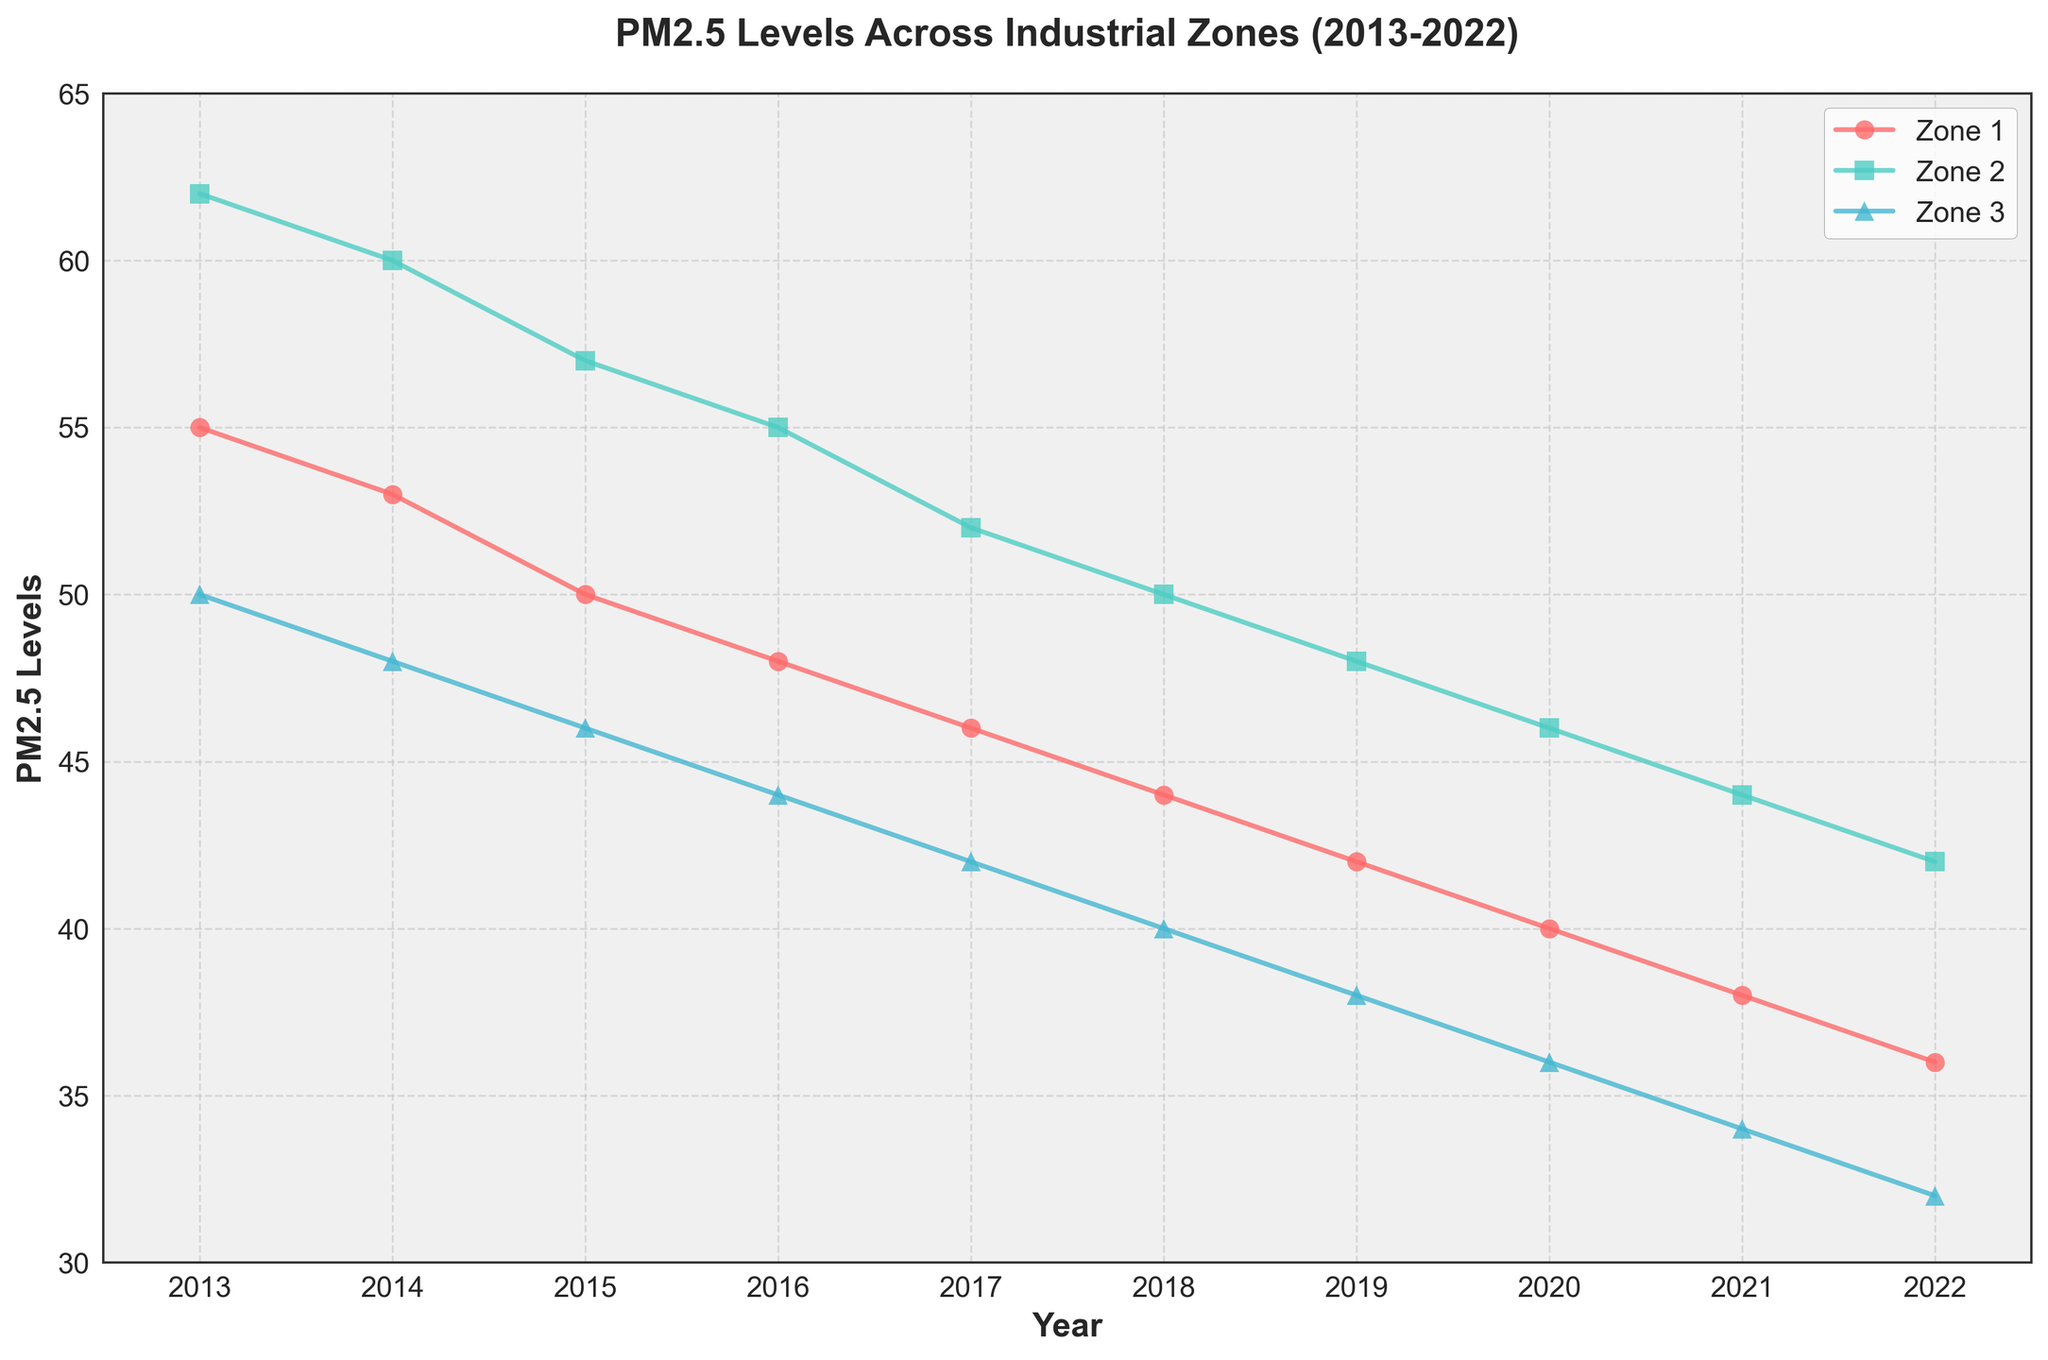What's the trend in PM2.5 levels for Zone 3 from 2013 to 2022? Look at the curve for Zone 3. PM2.5 levels start from 50 in 2013 and consistently decrease to 32 in 2022.
Answer: Decreasing trend Which zone had the highest PM2.5 level in 2013? Compare the PM2.5 values for all zones in 2013. Zone 2 had a PM2.5 level of 62, which is the highest among the three zones for that year.
Answer: Zone 2 How does the PM2.5 level in Zone 1 change from 2015 to 2022? Observe the PM2.5 levels for Zone 1 from 2015 (50) to 2022 (36). There is a steady decrease over these years.
Answer: Steadily decreases What is the average PM2.5 level for Zone 2 over the decade? To find the average, sum up the PM2.5 values for Zone 2 from 2013 to 2022 and divide by the number of years. (62 + 60 + 57 + 55 + 52 + 50 + 48 + 46 + 44 + 42) / 10 = 516 / 10 = 51.6
Answer: 51.6 Which year saw the lowest PM2.5 level in Zone 3? Check the PM2.5 levels for Zone 3 across all years. The lowest value is 32 in 2022.
Answer: 2022 How do the PM2.5 levels in Zone 2 compare to Zone 1 in 2020? Examine the PM2.5 values for both zones in 2020. Zone 2 has 46, while Zone 1 has 40.
Answer: Zone 2 has higher PM2.5 levels What’s the difference in PM2.5 levels between Zone 1 and Zone 3 in 2019? Subtract the PM2.5 level of Zone 3 from Zone 1 in 2019. Zone 1 has 42, and Zone 3 has 38. So, 42 - 38 = 4.
Answer: 4 Which zone shows the most significant decrease in PM2.5 levels from 2013 to 2022? Calculate the decrease for each zone by subtracting the PM2.5 level in 2022 from the level in 2013. Zone 1: 55-36=19, Zone 2: 62-42=20, Zone 3: 50-32=18. Zone 2 has the most significant decrease of 20 units.
Answer: Zone 2 